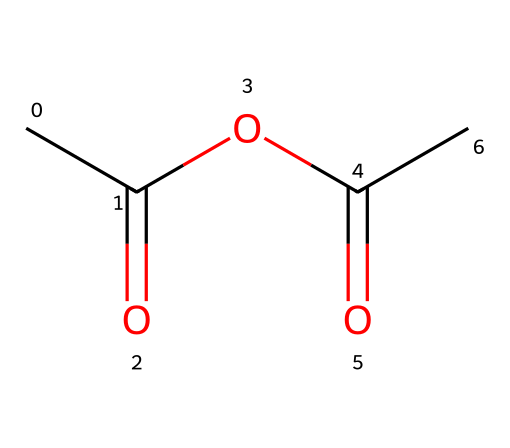What is the functional group present in acetic anhydride? Acetic anhydride contains an anhydride functional group, which is indicated by the structural representation showing two acyl groups (RCO) linked through an oxygen atom (O).
Answer: anhydride How many carbon atoms are in acetic anhydride? By analyzing the SMILES representation, we can count the carbon atoms (C). The structure CC(=O)OC(=O)C includes four carbon atoms.
Answer: four How many oxygen atoms are present in acetic anhydride? In the SMILES representation, there are two carbonyl oxygens (O) and one ether oxygen (O), totaling three oxygen atoms.
Answer: three What type of chemical is acetic anhydride? Acetic anhydride is classified specifically as an acid anhydride due to its structure, which consists of two acyl groups derived from acetic acid.
Answer: acid anhydride What are the predicted boiling and melting points of acetic anhydride? Based on typical properties of acetic anhydride and its molecular weight, it has a boiling point of approximately 140 degrees Celsius and a melting point of approximately -7 degrees Celsius.
Answer: 140 degrees Celsius, -7 degrees Celsius What can acetic anhydride be used for in sports equipment? Acetic anhydride is commonly used as a reagent in various chemical reactions and is employed in coatings for sports equipment due to its properties that enhance adhesion and durability.
Answer: coatings 